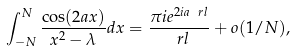<formula> <loc_0><loc_0><loc_500><loc_500>\int _ { - N } ^ { N } \frac { \cos ( 2 a x ) } { x ^ { 2 } - \lambda } d x = \frac { \pi i e ^ { 2 i a \ r l } } { \ r l } + o ( 1 / N ) ,</formula> 